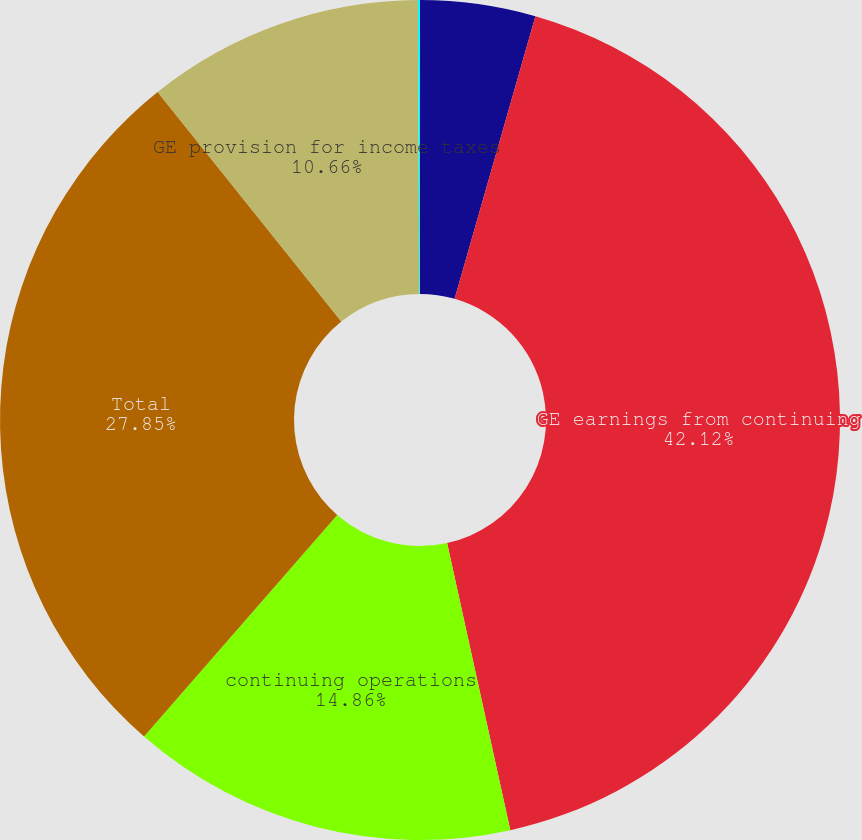Convert chart. <chart><loc_0><loc_0><loc_500><loc_500><pie_chart><fcel>(Dollars in millions)<fcel>GE earnings from continuing<fcel>continuing operations<fcel>Total<fcel>GE provision for income taxes<fcel>GE effective tax rate<nl><fcel>4.43%<fcel>42.12%<fcel>14.86%<fcel>27.85%<fcel>10.66%<fcel>0.08%<nl></chart> 